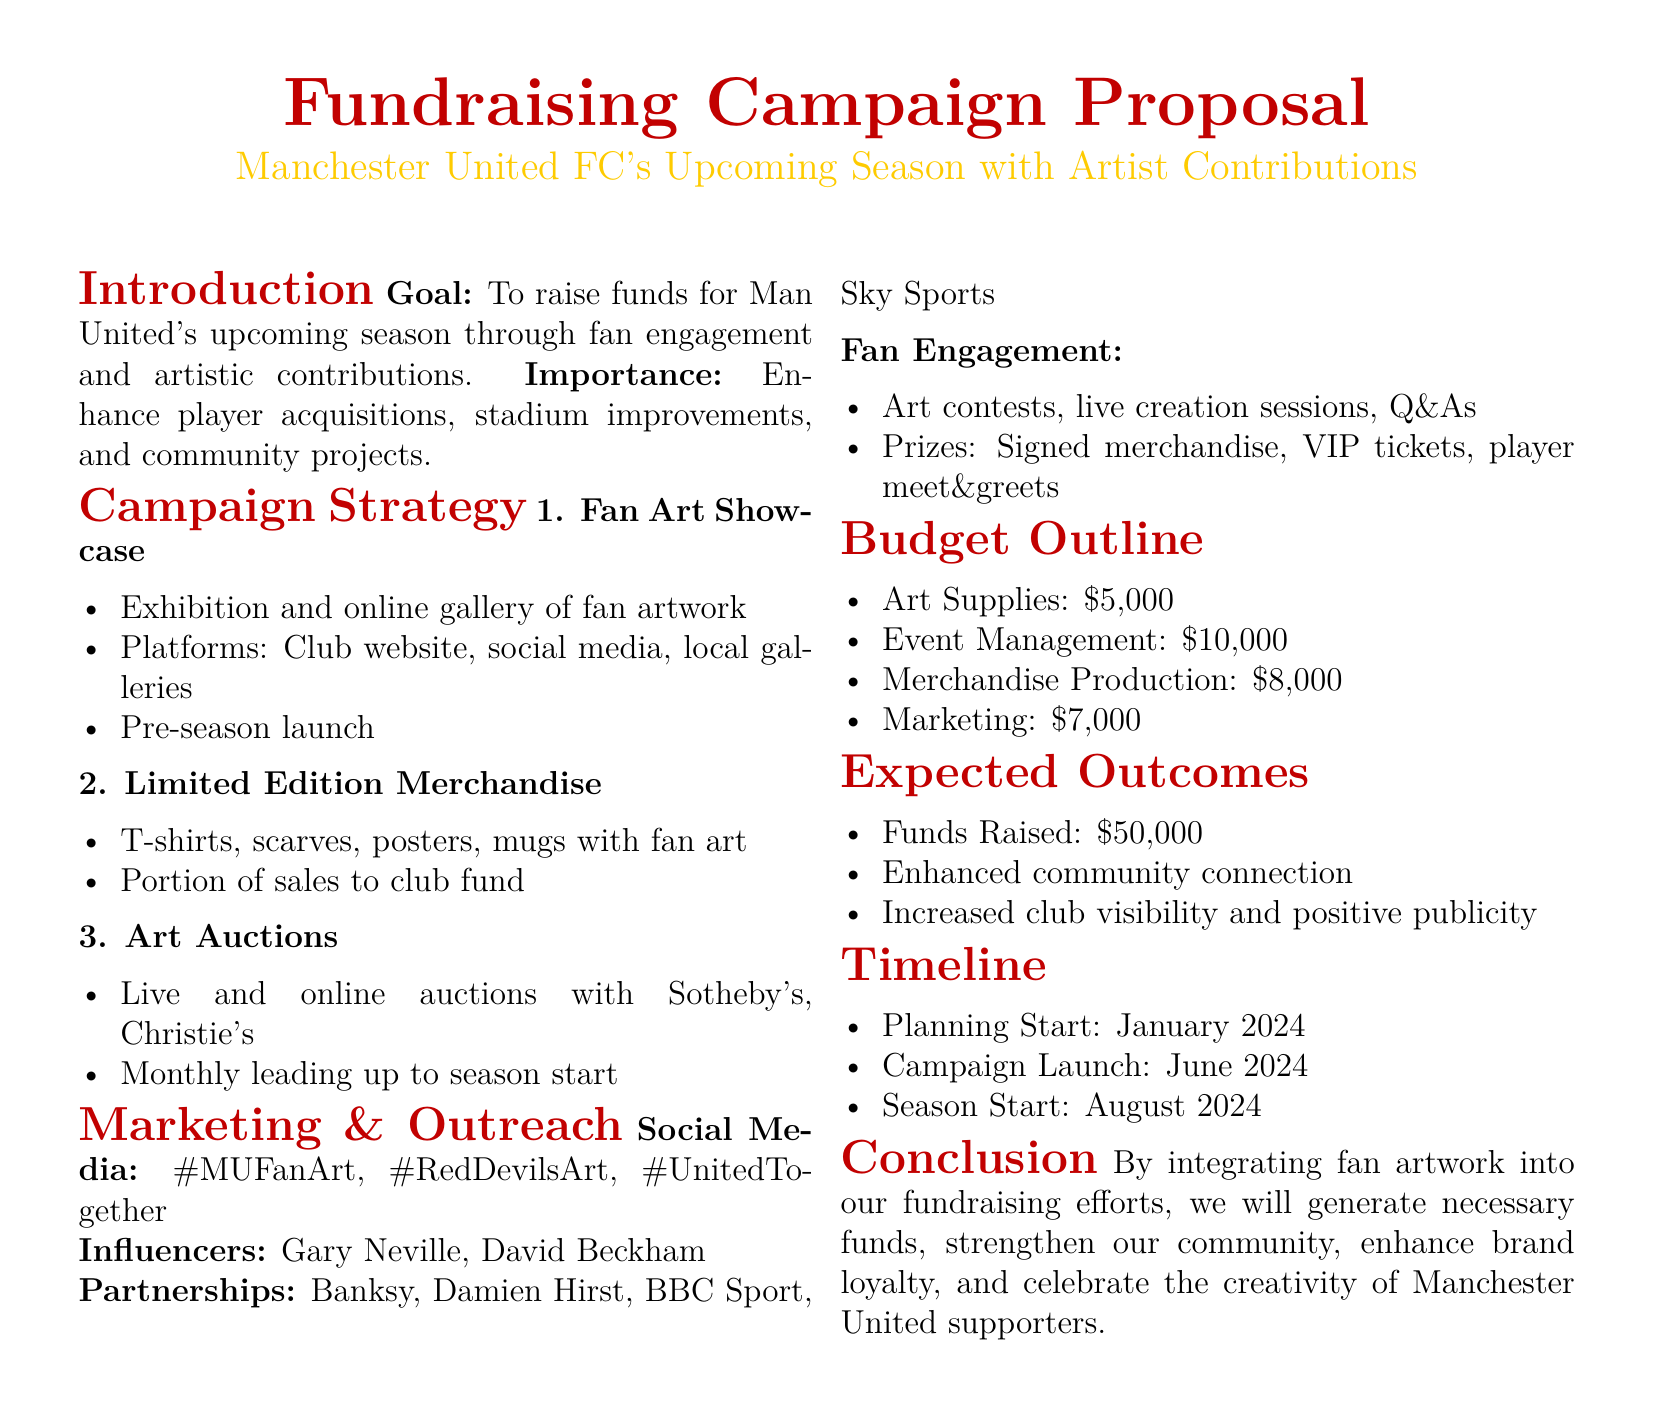What is the fundraising goal? The fundraising goal is stated in the introduction of the document as the amount intended to be raised for the club's upcoming season.
Answer: To raise funds for Man United's upcoming season through fan engagement and artistic contributions What are the platforms for the fan art showcase? The document lists the platforms where the fan art will be exhibited, which include the club's website and other venues.
Answer: Club website, social media, local galleries How much funding is allocated for marketing? The budget outline specifies the amount set aside for marketing efforts in the campaign.
Answer: $7,000 When does the campaign launch? The document provides a timeline indicating the launch date for the fundraising campaign.
Answer: June 2024 What are the expected funds raised? The expected outcomes section details how much money is anticipated to be raised through the campaign.
Answer: $50,000 What is one type of merchandise to be produced? The document mentions specific merchandise that will feature fan art and contribute to fundraising.
Answer: T-shirts, scarves, posters, mugs Who is one of the influencers mentioned for marketing? The marketing section of the document lists prominent individuals expected to help promote the campaign.
Answer: Gary Neville What is the start date for planning? The timeline in the document specifies when the planning for the campaign will commence.
Answer: January 2024 